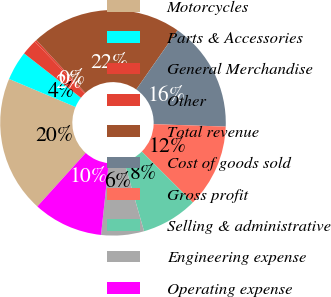Convert chart. <chart><loc_0><loc_0><loc_500><loc_500><pie_chart><fcel>Motorcycles<fcel>Parts & Accessories<fcel>General Merchandise<fcel>Other<fcel>Total revenue<fcel>Cost of goods sold<fcel>Gross profit<fcel>Selling & administrative<fcel>Engineering expense<fcel>Operating expense<nl><fcel>19.65%<fcel>4.19%<fcel>2.25%<fcel>0.31%<fcel>21.59%<fcel>15.83%<fcel>11.95%<fcel>8.07%<fcel>6.13%<fcel>10.01%<nl></chart> 